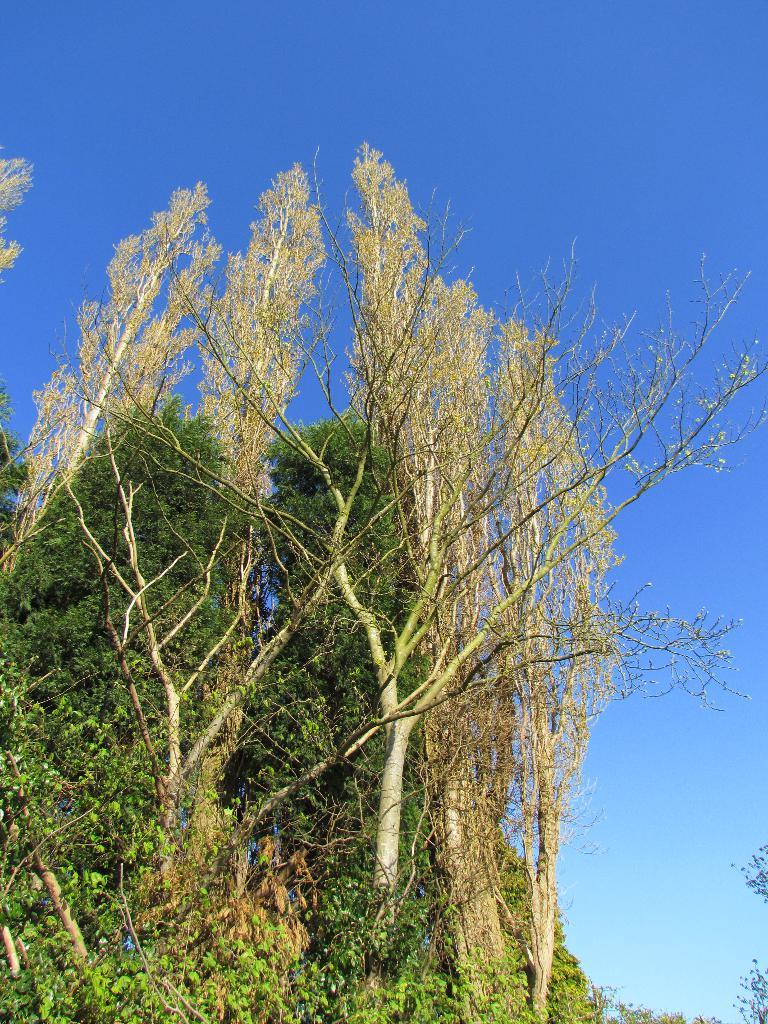What type of vegetation can be seen in the image? There are trees in the image. What colors are present on the trees in the image? The trees have green and yellow colors. What is visible in the background of the image? The sky is visible in the background of the image. How many hands are visible holding the trees in the image? There are no hands visible holding the trees in the image. What season is depicted in the image, considering the colors of the trees? The colors of the trees, green and yellow, do not necessarily indicate a specific season, as trees can have these colors at different times of the year. 